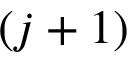<formula> <loc_0><loc_0><loc_500><loc_500>( j + 1 )</formula> 